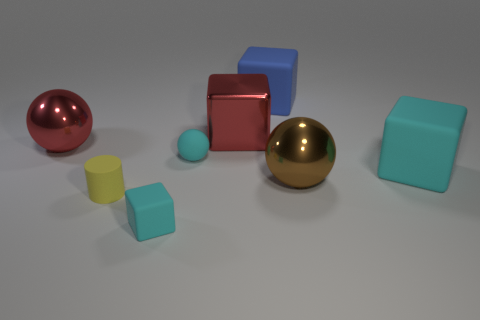Subtract all gray spheres. How many cyan cubes are left? 2 Subtract all blue cubes. How many cubes are left? 3 Subtract all big metal spheres. How many spheres are left? 1 Add 2 cyan matte blocks. How many objects exist? 10 Subtract all purple blocks. Subtract all gray spheres. How many blocks are left? 4 Subtract all balls. How many objects are left? 5 Add 4 large red metallic blocks. How many large red metallic blocks exist? 5 Subtract 0 blue cylinders. How many objects are left? 8 Subtract all tiny metallic cylinders. Subtract all large matte cubes. How many objects are left? 6 Add 2 large cubes. How many large cubes are left? 5 